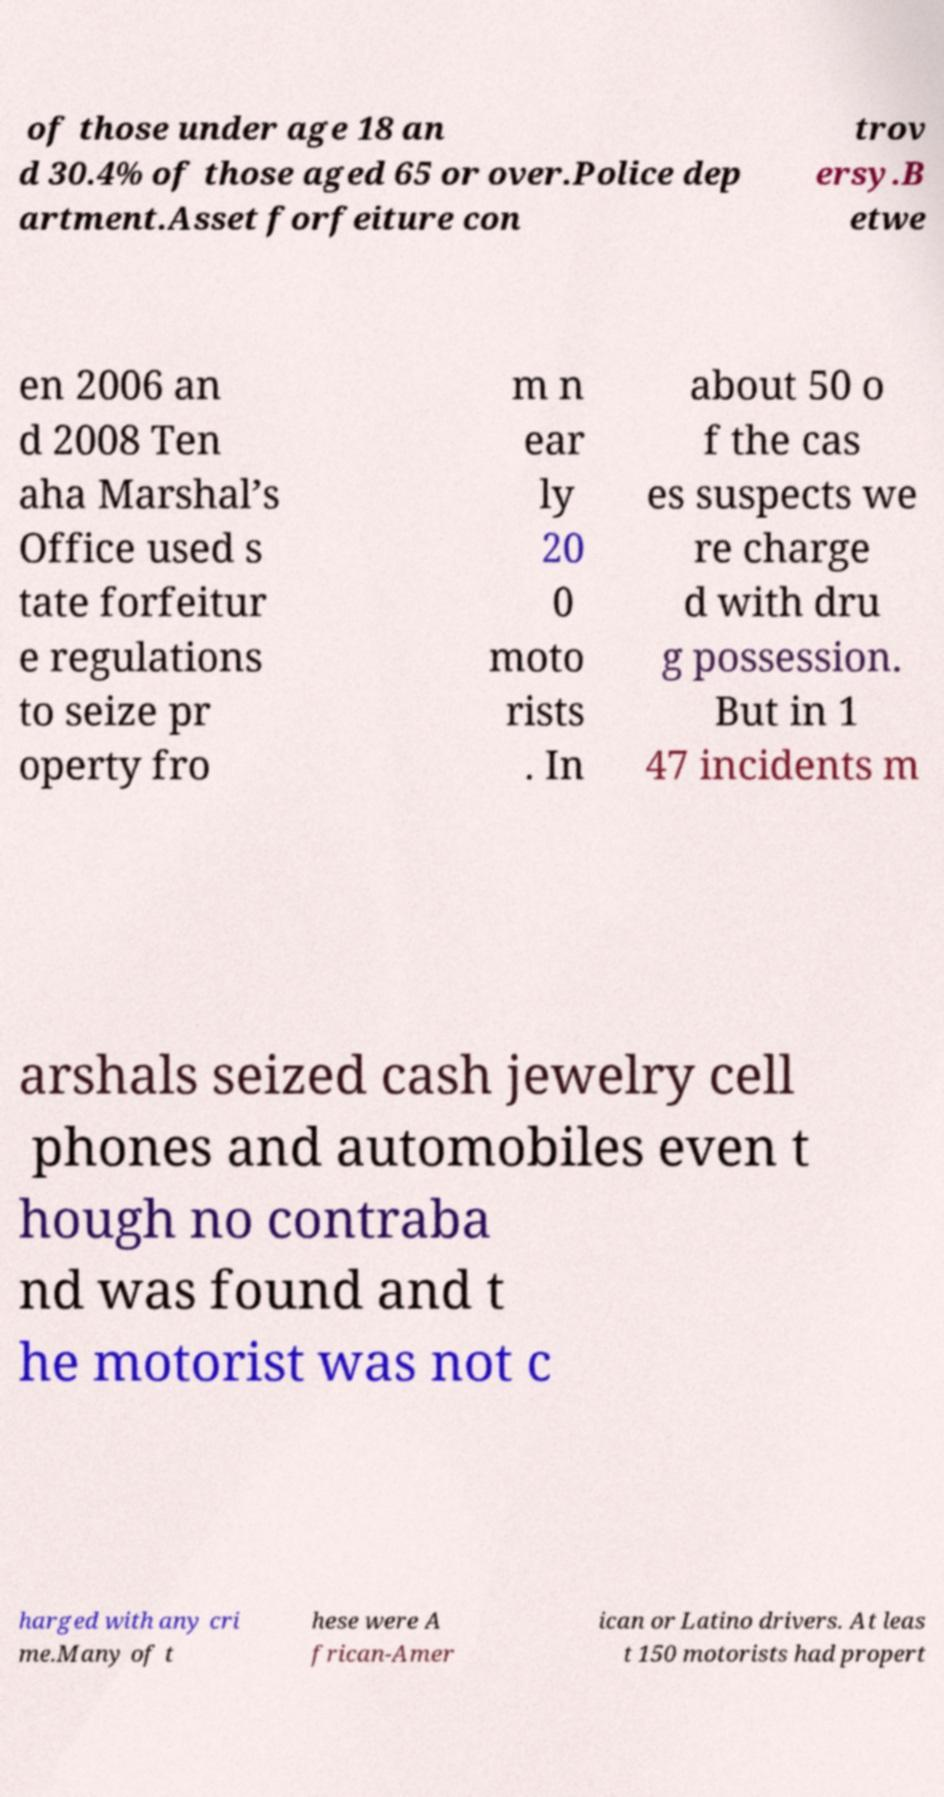Please read and relay the text visible in this image. What does it say? of those under age 18 an d 30.4% of those aged 65 or over.Police dep artment.Asset forfeiture con trov ersy.B etwe en 2006 an d 2008 Ten aha Marshal’s Office used s tate forfeitur e regulations to seize pr operty fro m n ear ly 20 0 moto rists . In about 50 o f the cas es suspects we re charge d with dru g possession. But in 1 47 incidents m arshals seized cash jewelry cell phones and automobiles even t hough no contraba nd was found and t he motorist was not c harged with any cri me.Many of t hese were A frican-Amer ican or Latino drivers. At leas t 150 motorists had propert 